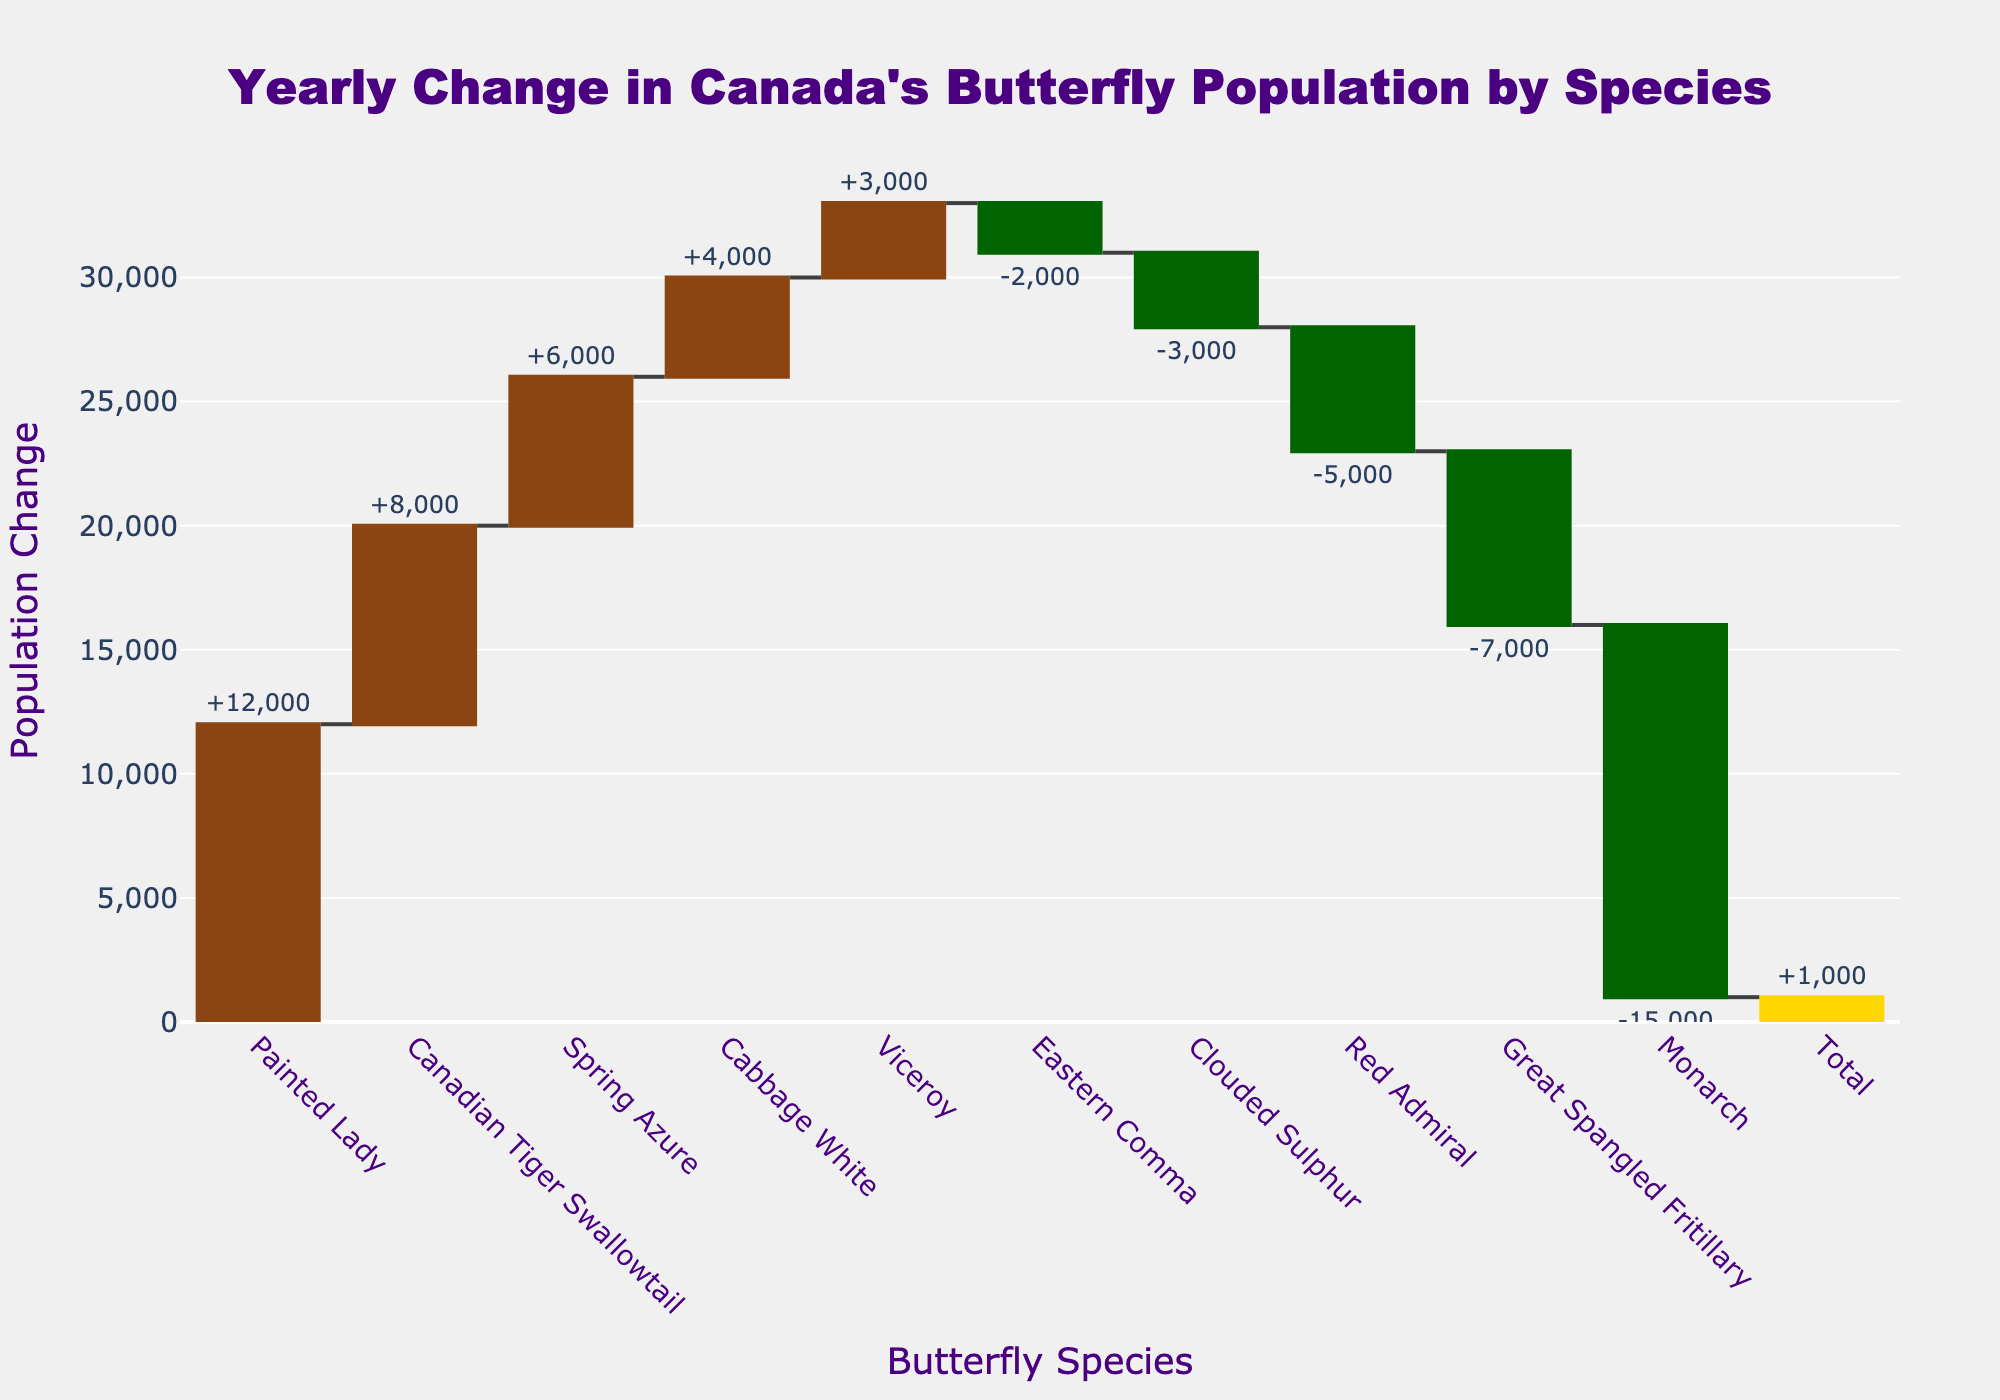What's the title of the chart? The title of the chart is displayed prominently at the top of the figure. It reads "Yearly Change in Canada's Butterfly Population by Species."
Answer: Yearly Change in Canada's Butterfly Population by Species What does the golden bar at the end represent? The golden bar at the end of the chart represents the total change in the butterfly population across all species. It is labeled "Total" and is in golden color to distinguish it from the other bars.
Answer: Total Which butterfly species experienced the largest decline? To identify the species with the largest decline, look for the largest downward bar on the chart. The Monarch butterfly has the largest decline with a change of -15,000.
Answer: Monarch How many species had an increase in their population? To find this, count the number of bars that extend upwards. There are four species: Canadian Tiger Swallowtail, Painted Lady, Spring Azure, and Cabbage White.
Answer: 4 What is the net change in the butterfly population for all species combined? The net change is represented by the golden "Total" bar at the end of the chart, which indicates the overall population change when all individual changes are summed up. The total change is +1,000.
Answer: +1,000 Which species saw a population increase of exactly 12,000? Look for the species with an upward bar that is labeled with a population change of +12,000. This species is the Painted Lady.
Answer: Painted Lady Compare the changes for the Monarch and Painted Lady species. Which one saw a larger absolute change? The Monarch's change is -15,000 and the Painted Lady's change is +12,000. The absolute change is the same as the magnitude of the number without considering the sign.
Answer: Monarch (15,000) What color are the bars representing species with a population increase? The color of the bars representing species with a population increase is a rich brown color, as seen in the Canadian Tiger Swallowtail, Painted Lady, Spring Azure, and Cabbage White.
Answer: Brown Which species experienced a population decrease of 3,000? Find the downward bar that is labeled with a population change of -3,000. The species is Clouded Sulphur.
Answer: Clouded Sulphur How many species experienced a population decrease? Count the number of bars that extend downwards. There are five species: Monarch, Red Admiral, Clouded Sulphur, Eastern Comma, and Great Spangled Fritillary.
Answer: 5 